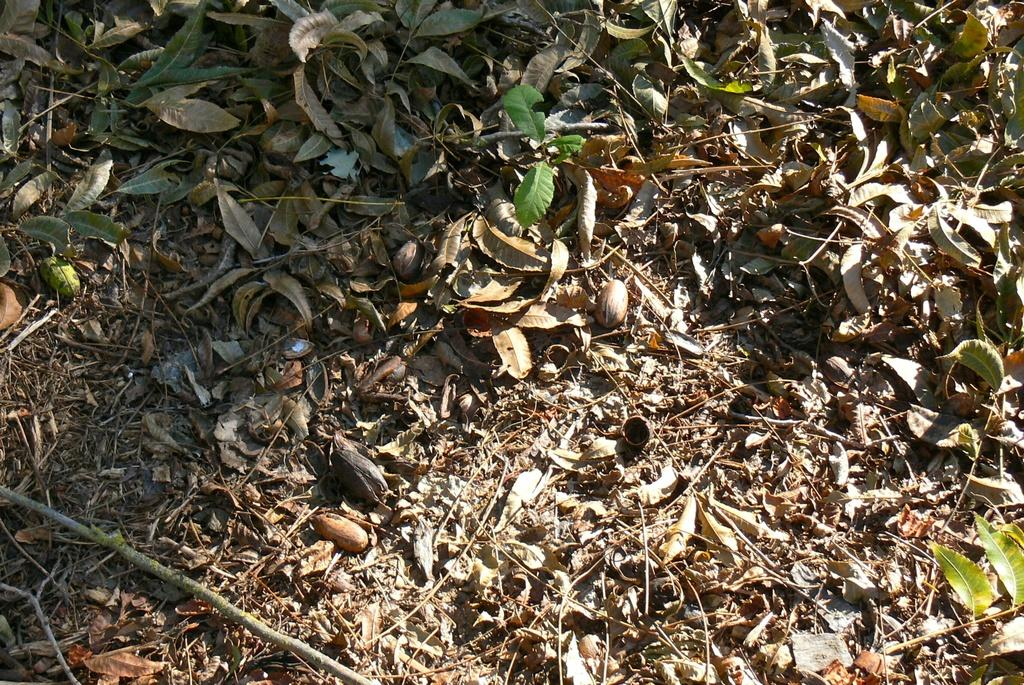What type of natural elements can be seen in the image? There are leaves and twigs in the image. What is the ground covered with in the image? There are objects on the ground in the image. What type of music is the band playing in the image? There is no band present in the image. What is the temperature of the objects on the ground in the image? The provided facts do not mention the temperature of the objects on the ground, so it cannot be determined from the image. 